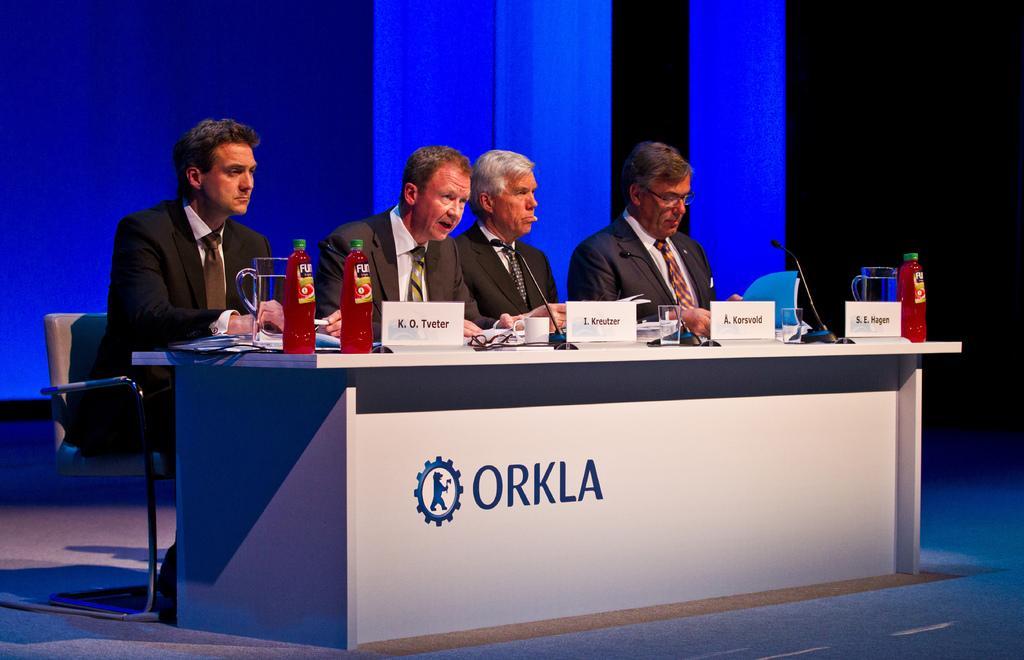Could you give a brief overview of what you see in this image? There is a table on which there are glasses, bottles, name plates and microphones. 4 people are seated wearing suit. 